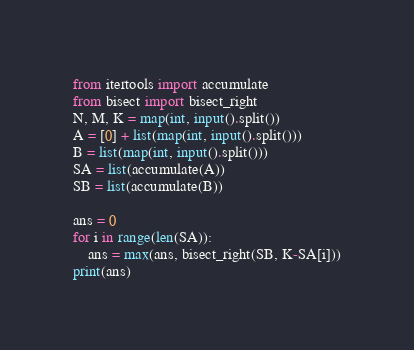Convert code to text. <code><loc_0><loc_0><loc_500><loc_500><_Python_>from itertools import accumulate
from bisect import bisect_right
N, M, K = map(int, input().split())
A = [0] + list(map(int, input().split()))
B = list(map(int, input().split()))
SA = list(accumulate(A))
SB = list(accumulate(B))

ans = 0
for i in range(len(SA)):
    ans = max(ans, bisect_right(SB, K-SA[i]))
print(ans)</code> 